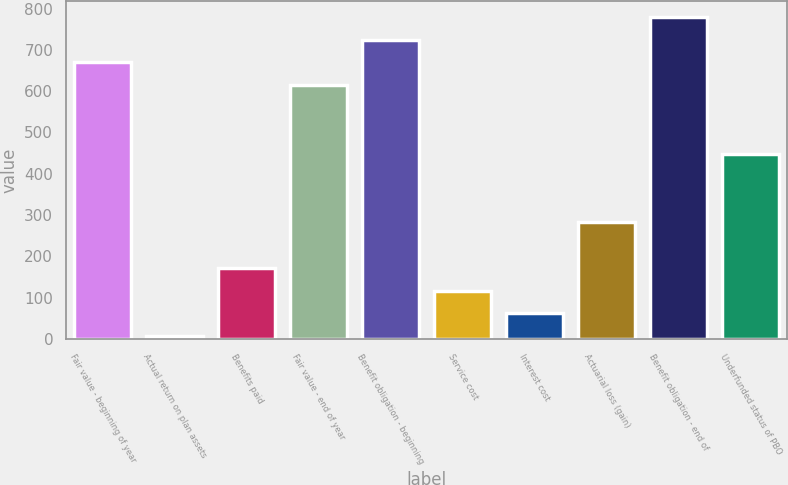Convert chart. <chart><loc_0><loc_0><loc_500><loc_500><bar_chart><fcel>Fair value - beginning of year<fcel>Actual return on plan assets<fcel>Benefits paid<fcel>Fair value - end of year<fcel>Benefit obligation - beginning<fcel>Service cost<fcel>Interest cost<fcel>Actuarial loss (gain)<fcel>Benefit obligation - end of<fcel>Underfunded status of PBO<nl><fcel>669.4<fcel>7<fcel>172.6<fcel>614.2<fcel>724.6<fcel>117.4<fcel>62.2<fcel>283<fcel>779.8<fcel>448.6<nl></chart> 